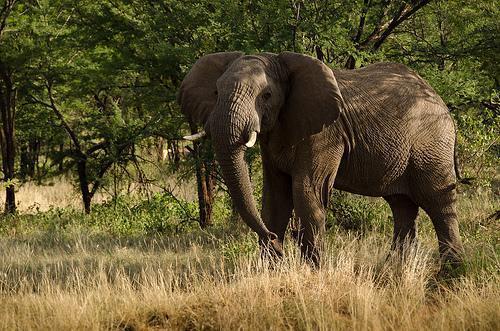How many elephants are pictured?
Give a very brief answer. 1. 